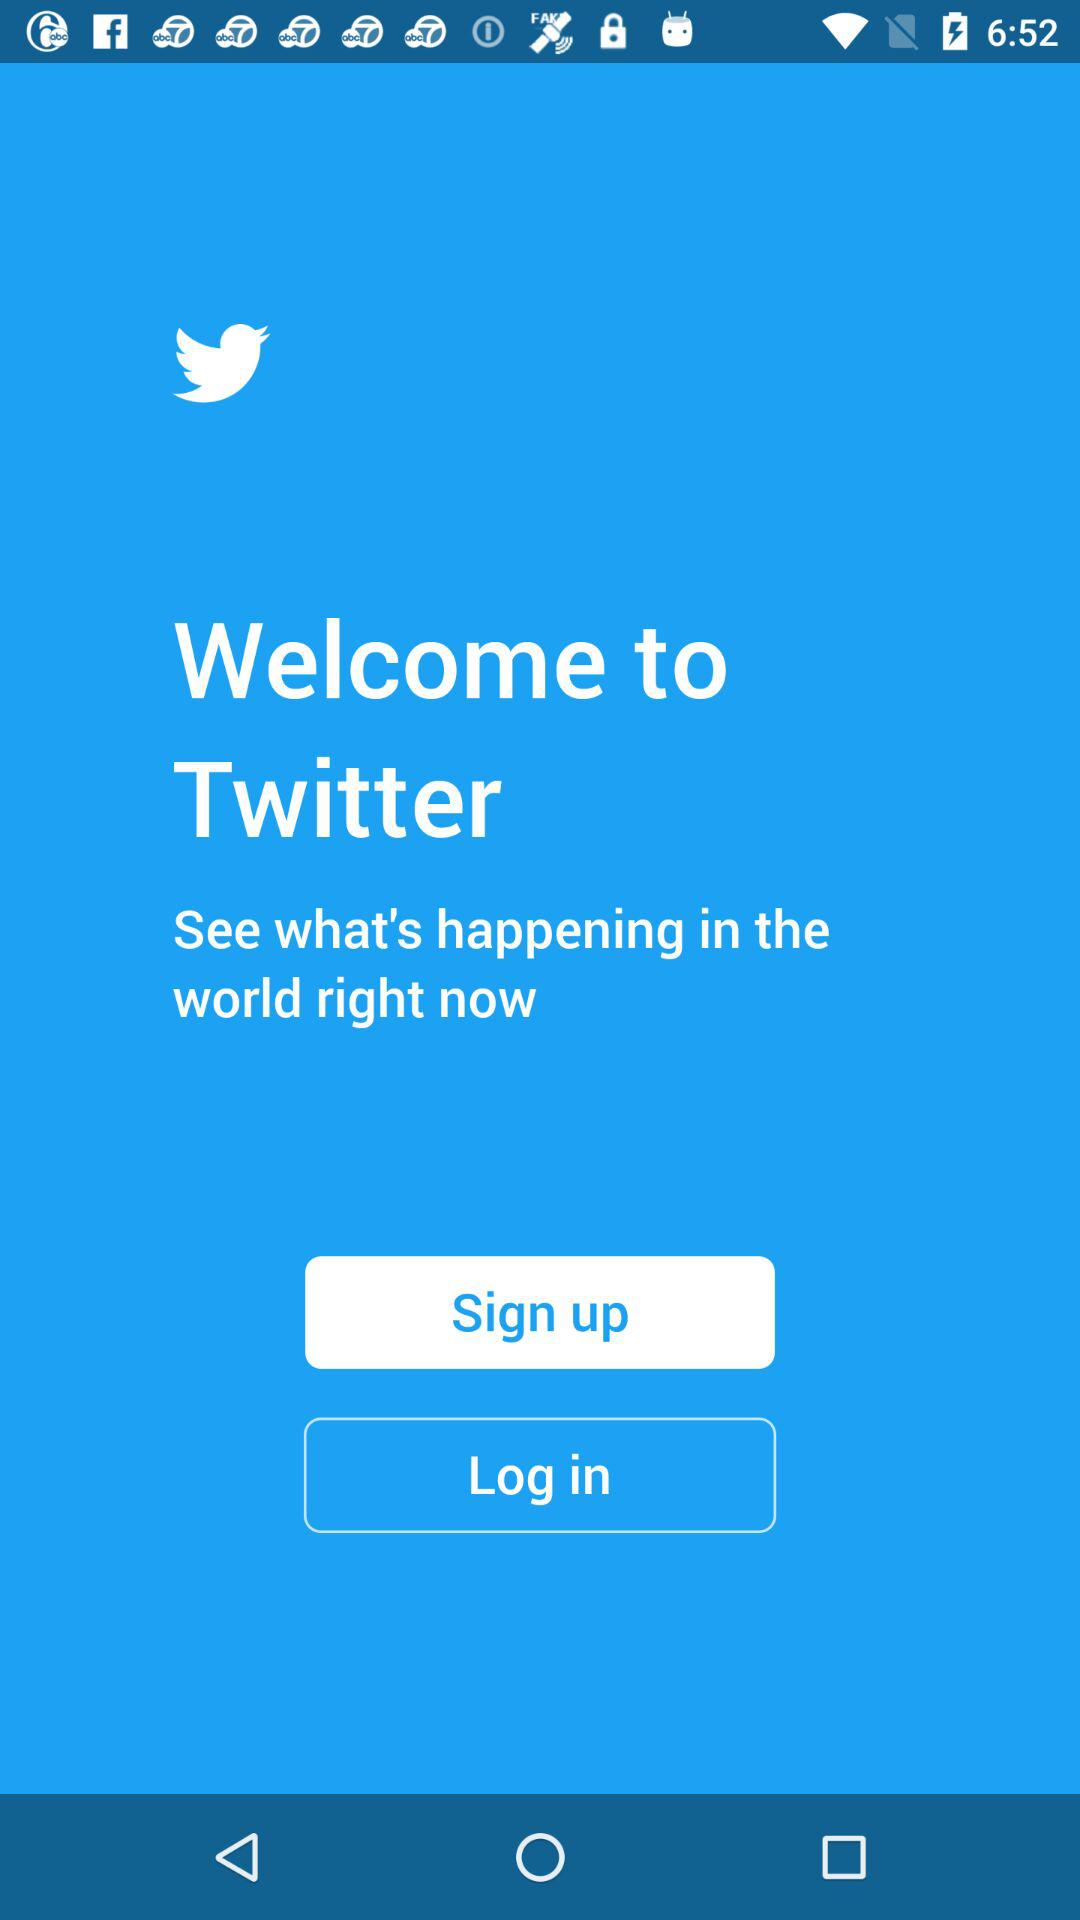What is the name of the application? The name of the application is "Twitter". 